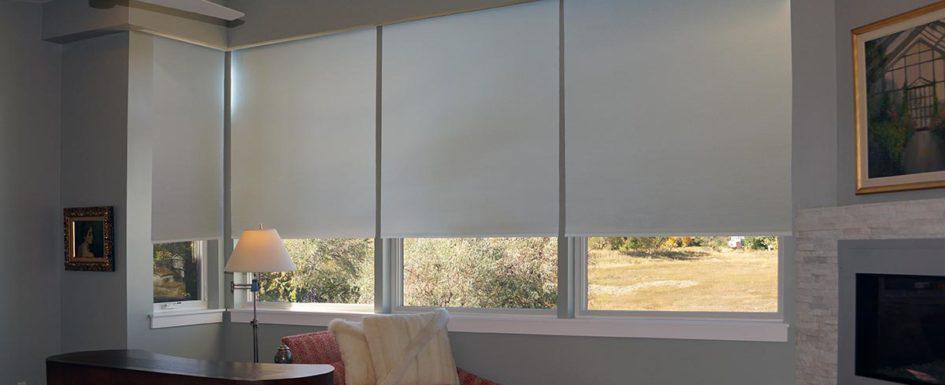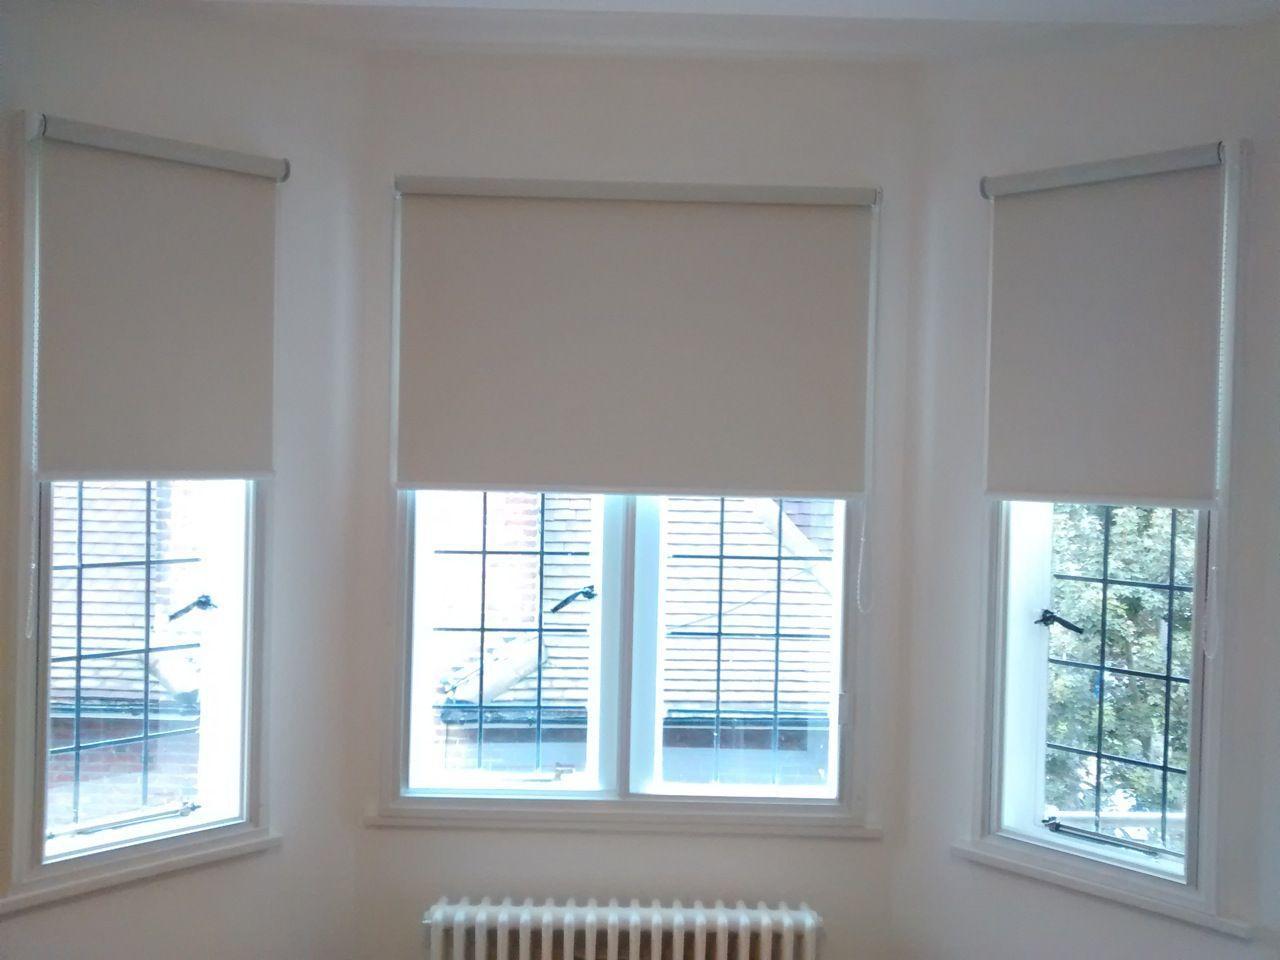The first image is the image on the left, the second image is the image on the right. Analyze the images presented: Is the assertion "all the shades in the right image are partially open." valid? Answer yes or no. Yes. The first image is the image on the left, the second image is the image on the right. Evaluate the accuracy of this statement regarding the images: "An image shows three neutral-colored shades in a row on a straight wall, each covering at least 2/3 of a pane-less window.". Is it true? Answer yes or no. Yes. 